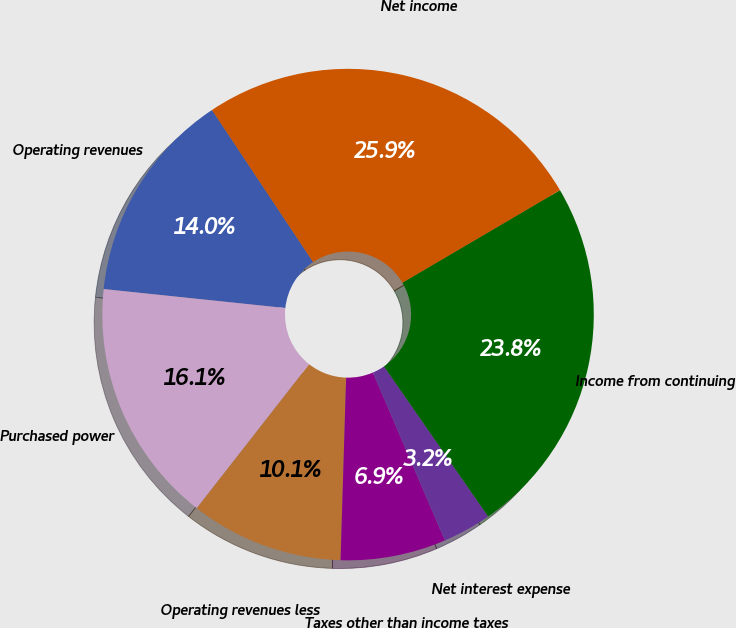Convert chart. <chart><loc_0><loc_0><loc_500><loc_500><pie_chart><fcel>Operating revenues<fcel>Purchased power<fcel>Operating revenues less<fcel>Taxes other than income taxes<fcel>Net interest expense<fcel>Income from continuing<fcel>Net income<nl><fcel>14.0%<fcel>16.1%<fcel>10.07%<fcel>6.93%<fcel>3.21%<fcel>23.79%<fcel>25.89%<nl></chart> 